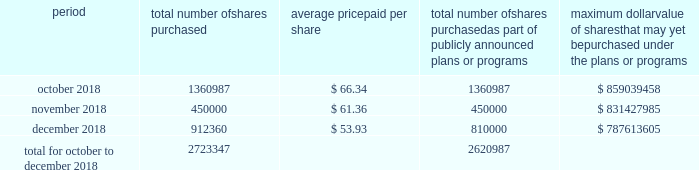Table of content part ii item 5 .
Market for the registrant's common equity , related stockholder matters and issuer purchases of equity securities our common stock is traded on the new york stock exchange under the trading symbol 201chfc . 201d in september 2018 , our board of directors approved a $ 1 billion share repurchase program , which replaced all existing share repurchase programs , authorizing us to repurchase common stock in the open market or through privately negotiated transactions .
The timing and amount of stock repurchases will depend on market conditions and corporate , regulatory and other relevant considerations .
This program may be discontinued at any time by the board of directors .
The table includes repurchases made under this program during the fourth quarter of 2018 .
Period total number of shares purchased average price paid per share total number of shares purchased as part of publicly announced plans or programs maximum dollar value of shares that may yet be purchased under the plans or programs .
During the quarter ended december 31 , 2018 , 102360 shares were withheld from certain executives and employees under the terms of our share-based compensation agreements to provide funds for the payment of payroll and income taxes due at vesting of restricted stock awards .
As of february 13 , 2019 , we had approximately 97419 stockholders , including beneficial owners holding shares in street name .
We intend to consider the declaration of a dividend on a quarterly basis , although there is no assurance as to future dividends since they are dependent upon future earnings , capital requirements , our financial condition and other factors. .
What was the range of shares bought between oct and dec 2018? 
Computations: (1360987 - 450000)
Answer: 910987.0. 